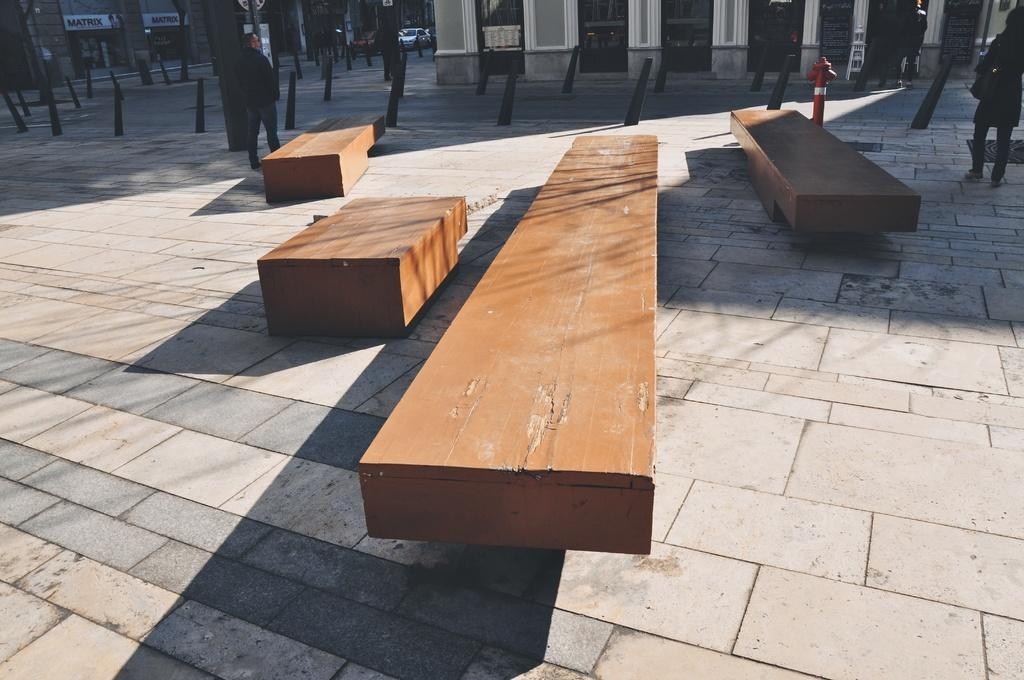What type of seating is visible in the foreground of the image? There are wooden benches in the foreground of the image. Can you describe the people in the image? There are people in the image, but their specific actions or appearances are not mentioned in the provided facts. What can be seen in the background of the image? There are buildings, small poles, and vehicles in the background of the image. What color is the ink on the eyes of the person in the image? There is no mention of ink or eyes in the provided facts, so we cannot answer this question based on the image. 